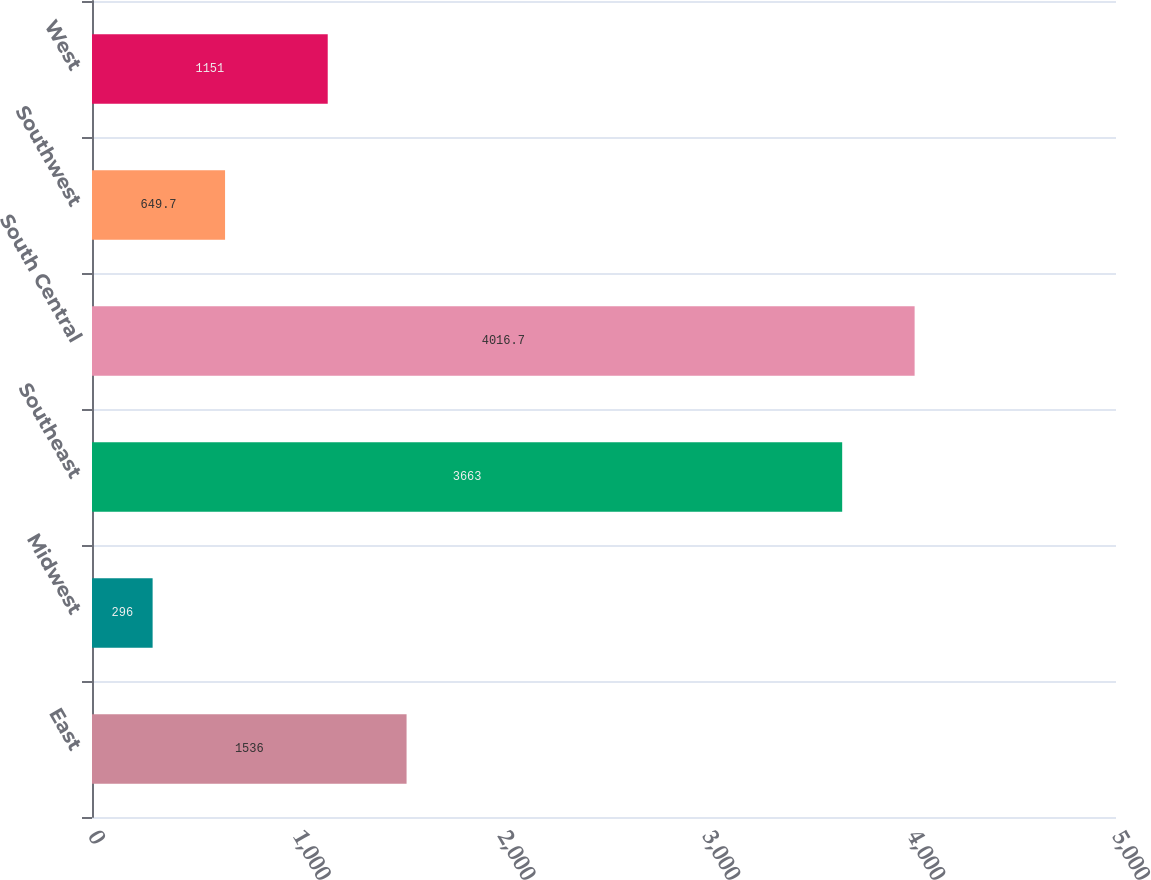Convert chart. <chart><loc_0><loc_0><loc_500><loc_500><bar_chart><fcel>East<fcel>Midwest<fcel>Southeast<fcel>South Central<fcel>Southwest<fcel>West<nl><fcel>1536<fcel>296<fcel>3663<fcel>4016.7<fcel>649.7<fcel>1151<nl></chart> 